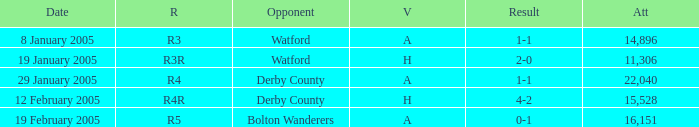What is the date where the round is R3? 8 January 2005. Parse the full table. {'header': ['Date', 'R', 'Opponent', 'V', 'Result', 'Att'], 'rows': [['8 January 2005', 'R3', 'Watford', 'A', '1-1', '14,896'], ['19 January 2005', 'R3R', 'Watford', 'H', '2-0', '11,306'], ['29 January 2005', 'R4', 'Derby County', 'A', '1-1', '22,040'], ['12 February 2005', 'R4R', 'Derby County', 'H', '4-2', '15,528'], ['19 February 2005', 'R5', 'Bolton Wanderers', 'A', '0-1', '16,151']]} 